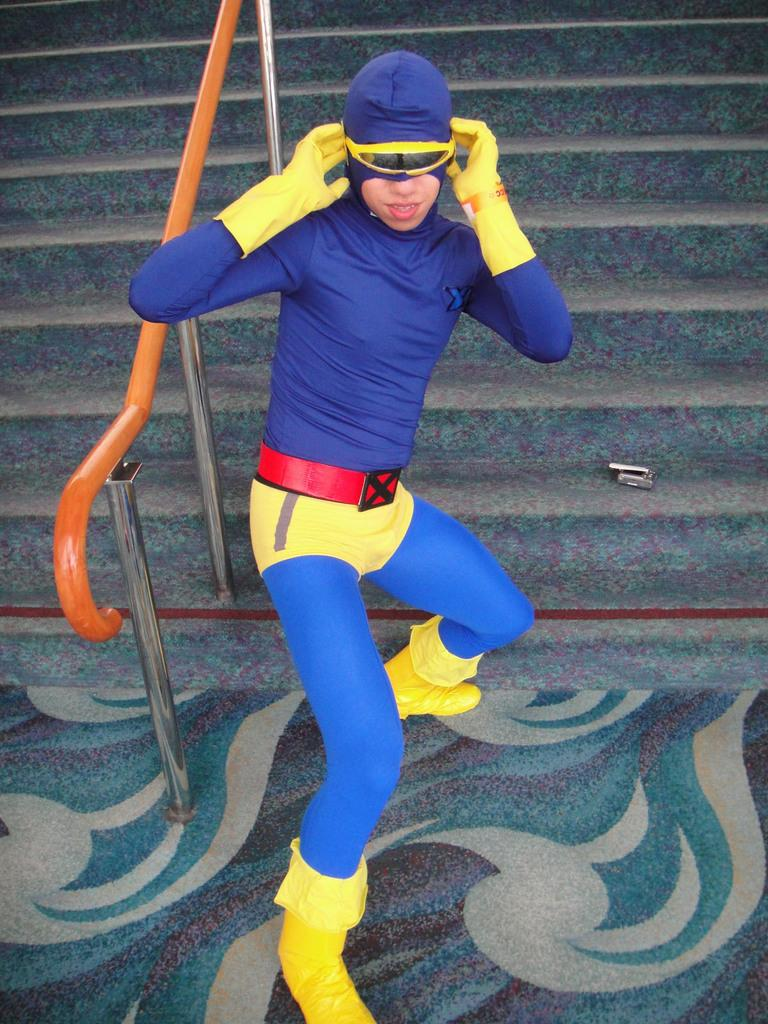What is the main subject of the image? There is a person standing in the center of the image. What is the person wearing? The person is wearing a blue t-shirt. What can be seen in the background of the image? There is a fence and a staircase in the background of the image. What type of blood is visible on the person's blue t-shirt in the image? There is no blood visible on the person's blue t-shirt in the image. What type of juice is being served on the staircase in the background of the image? There is no juice or any indication of a beverage in the image; it only features a person and background elements. 